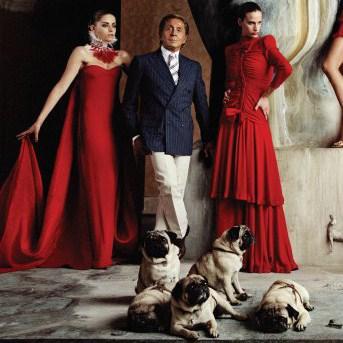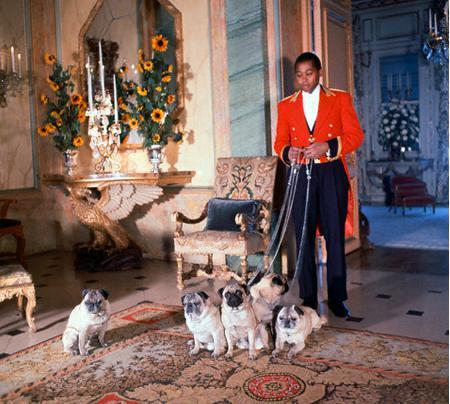The first image is the image on the left, the second image is the image on the right. Given the left and right images, does the statement "One of the images shows only one dog and one man." hold true? Answer yes or no. No. The first image is the image on the left, the second image is the image on the right. Given the left and right images, does the statement "The right image contains no more than one dog." hold true? Answer yes or no. No. 